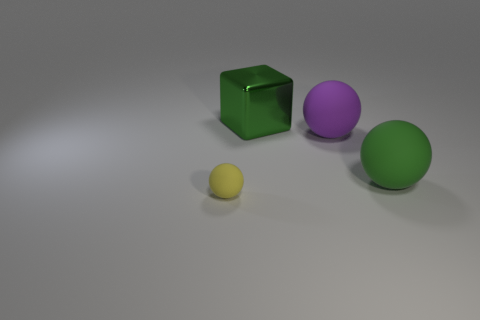Are there any other things that are made of the same material as the green cube?
Offer a very short reply. No. What material is the big sphere that is to the left of the green matte sphere?
Keep it short and to the point. Rubber. How many large things are rubber things or purple objects?
Provide a succinct answer. 2. Is there a large object made of the same material as the small ball?
Ensure brevity in your answer.  Yes. Does the green thing in front of the green metal object have the same size as the large purple sphere?
Give a very brief answer. Yes. There is a large sphere behind the object that is on the right side of the big purple rubber thing; are there any big green objects to the left of it?
Keep it short and to the point. Yes. What number of rubber things are tiny yellow objects or large things?
Offer a very short reply. 3. How many other things are there of the same shape as the large purple thing?
Offer a very short reply. 2. Is the number of green spheres greater than the number of big blue balls?
Your answer should be compact. Yes. What is the size of the sphere left of the rubber thing behind the green thing that is to the right of the large green metallic block?
Your answer should be very brief. Small. 